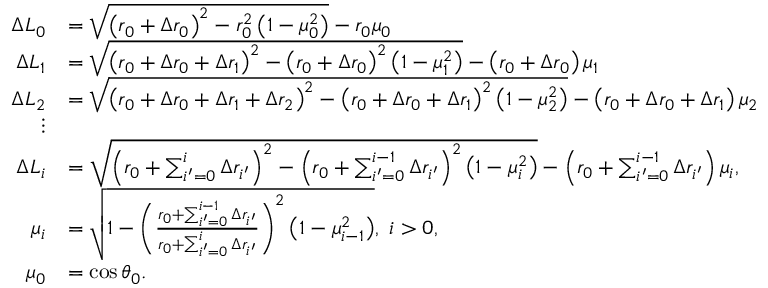Convert formula to latex. <formula><loc_0><loc_0><loc_500><loc_500>\begin{array} { r l } { \Delta L _ { 0 } } & { = \sqrt { \left ( r _ { 0 } + \Delta r _ { 0 } \right ) ^ { 2 } - r _ { 0 } ^ { 2 } \left ( 1 - \mu _ { 0 } ^ { 2 } \right ) } - r _ { 0 } \mu _ { 0 } } \\ { \Delta L _ { 1 } } & { = \sqrt { \left ( r _ { 0 } + \Delta r _ { 0 } + \Delta r _ { 1 } \right ) ^ { 2 } - \left ( r _ { 0 } + \Delta r _ { 0 } \right ) ^ { 2 } \left ( 1 - \mu _ { 1 } ^ { 2 } \right ) } - \left ( r _ { 0 } + \Delta r _ { 0 } \right ) \mu _ { 1 } } \\ { \Delta L _ { 2 } } & { = \sqrt { \left ( r _ { 0 } + \Delta r _ { 0 } + \Delta r _ { 1 } + \Delta r _ { 2 } \right ) ^ { 2 } - \left ( r _ { 0 } + \Delta r _ { 0 } + \Delta r _ { 1 } \right ) ^ { 2 } \left ( 1 - \mu _ { 2 } ^ { 2 } \right ) } - \left ( r _ { 0 } + \Delta r _ { 0 } + \Delta r _ { 1 } \right ) \mu _ { 2 } } \\ { \vdots } \\ { \Delta L _ { i } } & { = \sqrt { \left ( r _ { 0 } + \sum _ { i ^ { \prime } = 0 } ^ { i } \Delta r _ { i ^ { \prime } } \right ) ^ { 2 } - \left ( r _ { 0 } + \sum _ { i ^ { \prime } = 0 } ^ { i - 1 } \Delta r _ { i ^ { \prime } } \right ) ^ { 2 } \left ( 1 - \mu _ { i } ^ { 2 } \right ) } - \left ( r _ { 0 } + \sum _ { i ^ { \prime } = 0 } ^ { i - 1 } \Delta r _ { i ^ { \prime } } \right ) \mu _ { i } , } \\ { \mu _ { i } } & { = \sqrt { 1 - \left ( \frac { r _ { 0 } + \sum _ { i ^ { \prime } = 0 } ^ { i - 1 } \Delta r _ { i ^ { \prime } } } { r _ { 0 } + \sum _ { i ^ { \prime } = 0 } ^ { i } \Delta r _ { i ^ { \prime } } } \right ) ^ { 2 } \left ( 1 - \mu _ { i - 1 } ^ { 2 } \right ) } , \ i > 0 , } \\ { \mu _ { 0 } } & { = \cos \theta _ { 0 } . } \end{array}</formula> 